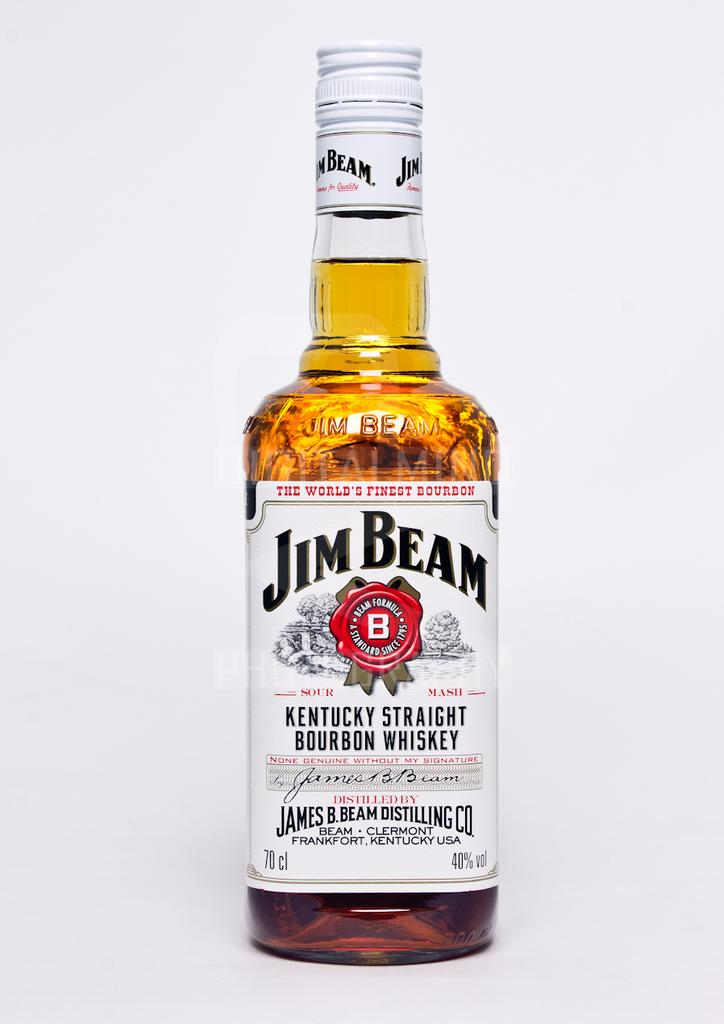<image>
Create a compact narrative representing the image presented. A bottle of Jim Beam Kentucky Straight Bourbon Whiskey. 